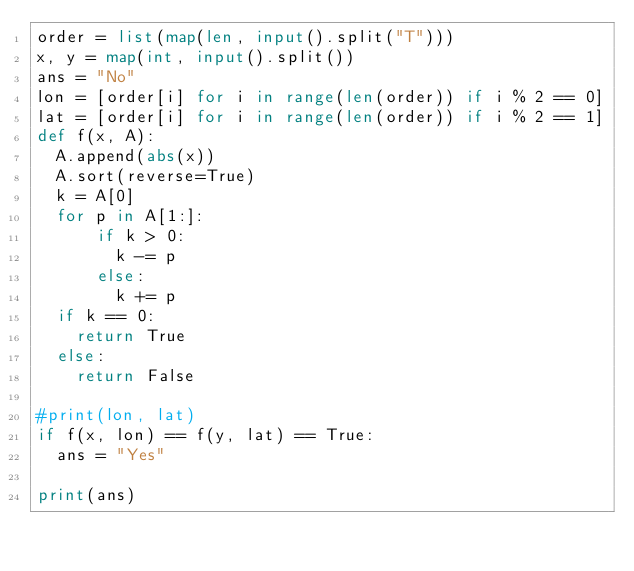Convert code to text. <code><loc_0><loc_0><loc_500><loc_500><_Python_>order = list(map(len, input().split("T")))
x, y = map(int, input().split())
ans = "No"
lon = [order[i] for i in range(len(order)) if i % 2 == 0]
lat = [order[i] for i in range(len(order)) if i % 2 == 1]
def f(x, A):
  A.append(abs(x))
  A.sort(reverse=True)
  k = A[0]
  for p in A[1:]:
      if k > 0:
        k -= p
      else:
        k += p
  if k == 0:
    return True
  else:
    return False
  
#print(lon, lat)
if f(x, lon) == f(y, lat) == True:
  ans = "Yes"
  
print(ans)</code> 